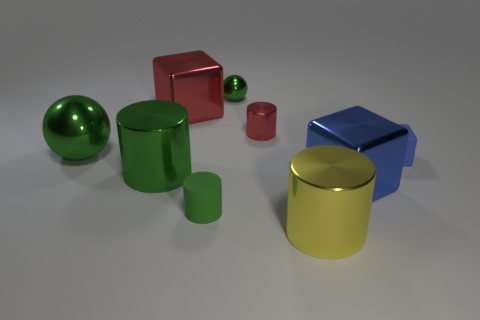How many other green cylinders have the same material as the small green cylinder?
Provide a short and direct response. 0. How many big metal cubes are there?
Give a very brief answer. 2. There is a red shiny block; does it have the same size as the green metallic ball that is behind the tiny red metallic thing?
Keep it short and to the point. No. What is the big block that is in front of the matte object behind the small green rubber cylinder made of?
Your answer should be very brief. Metal. There is a cube in front of the green shiny cylinder to the left of the metal cube that is to the left of the green matte object; what size is it?
Offer a terse response. Large. Is the shape of the large red thing the same as the red thing to the right of the red metal cube?
Offer a terse response. No. What is the material of the tiny red thing?
Your answer should be very brief. Metal. What number of matte things are cyan objects or big red blocks?
Your answer should be compact. 0. Are there fewer big green metal balls that are to the right of the large blue metallic cube than large shiny cylinders that are right of the tiny ball?
Keep it short and to the point. Yes. Are there any matte objects that are behind the large metallic cylinder behind the tiny thing in front of the blue matte block?
Ensure brevity in your answer.  Yes. 